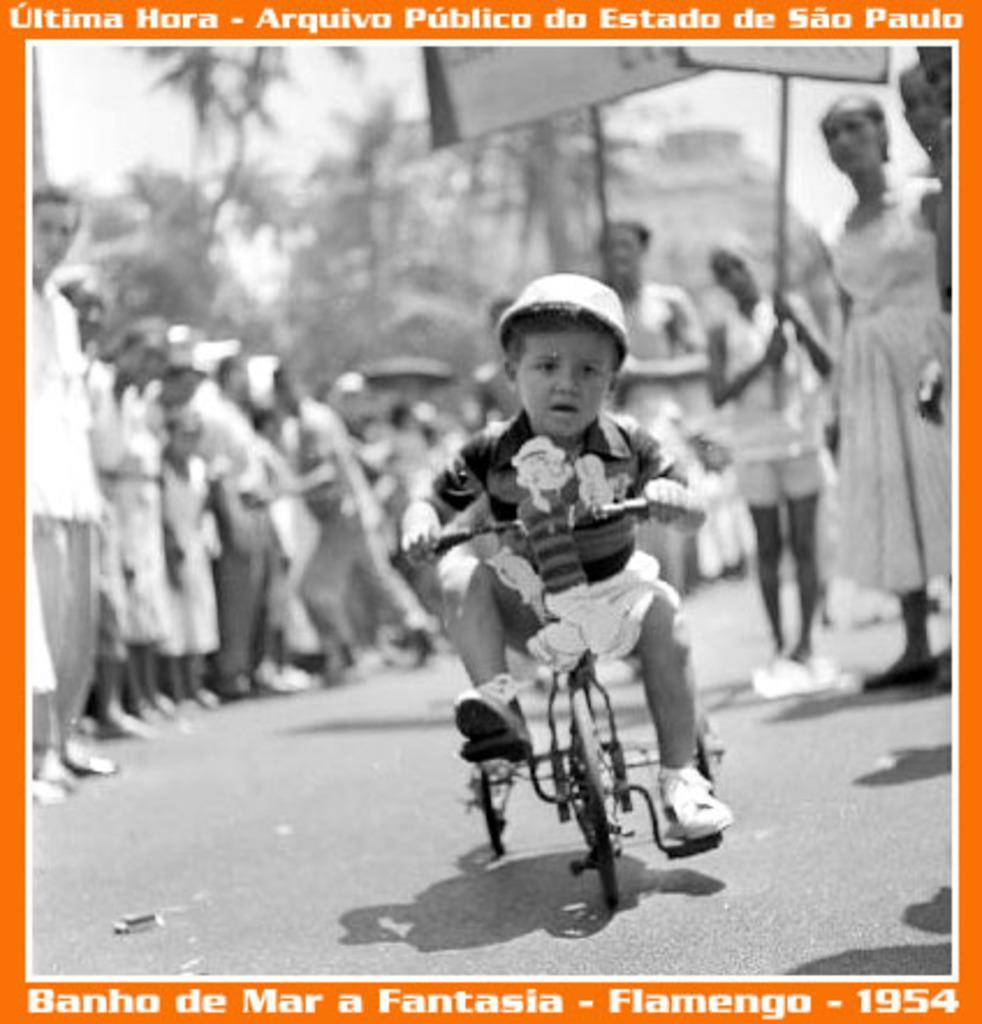Please provide a concise description of this image. In this image I can see a child is cycling a tricycle, I can also see he is wearing helmet. In the background I can see few more people are standing. 